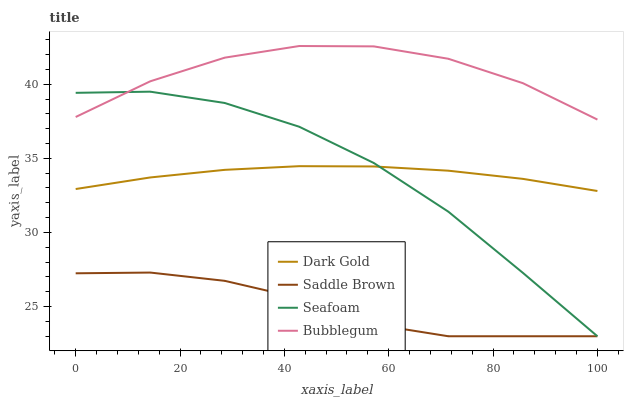Does Saddle Brown have the minimum area under the curve?
Answer yes or no. Yes. Does Bubblegum have the maximum area under the curve?
Answer yes or no. Yes. Does Bubblegum have the minimum area under the curve?
Answer yes or no. No. Does Saddle Brown have the maximum area under the curve?
Answer yes or no. No. Is Dark Gold the smoothest?
Answer yes or no. Yes. Is Bubblegum the roughest?
Answer yes or no. Yes. Is Saddle Brown the smoothest?
Answer yes or no. No. Is Saddle Brown the roughest?
Answer yes or no. No. Does Seafoam have the lowest value?
Answer yes or no. Yes. Does Bubblegum have the lowest value?
Answer yes or no. No. Does Bubblegum have the highest value?
Answer yes or no. Yes. Does Saddle Brown have the highest value?
Answer yes or no. No. Is Dark Gold less than Bubblegum?
Answer yes or no. Yes. Is Dark Gold greater than Saddle Brown?
Answer yes or no. Yes. Does Seafoam intersect Dark Gold?
Answer yes or no. Yes. Is Seafoam less than Dark Gold?
Answer yes or no. No. Is Seafoam greater than Dark Gold?
Answer yes or no. No. Does Dark Gold intersect Bubblegum?
Answer yes or no. No. 